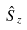Convert formula to latex. <formula><loc_0><loc_0><loc_500><loc_500>\hat { S } _ { z }</formula> 